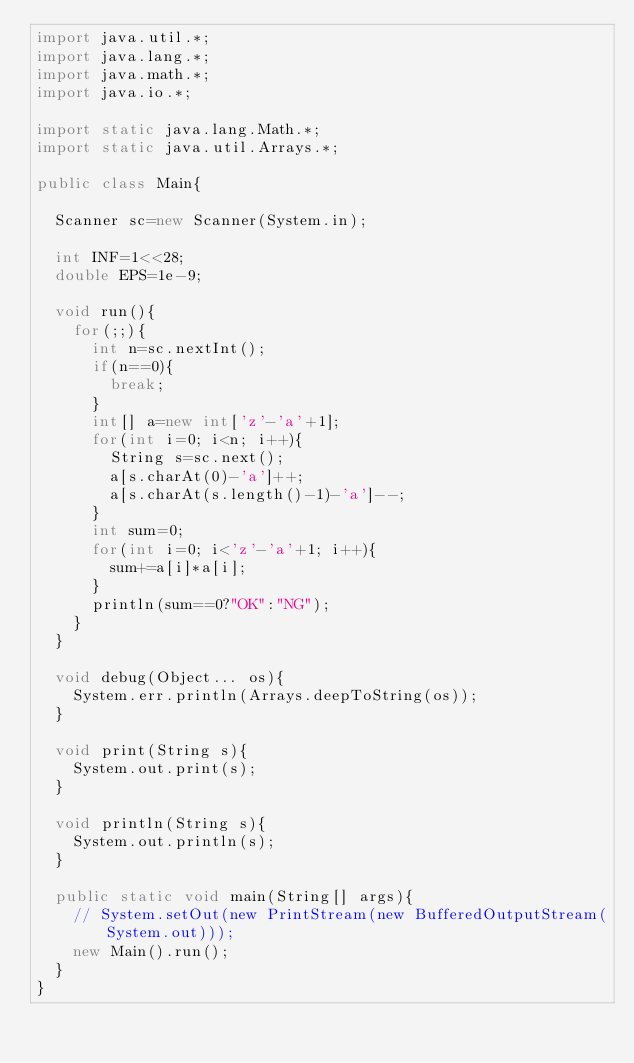Convert code to text. <code><loc_0><loc_0><loc_500><loc_500><_Java_>import java.util.*;
import java.lang.*;
import java.math.*;
import java.io.*;

import static java.lang.Math.*;
import static java.util.Arrays.*;

public class Main{

	Scanner sc=new Scanner(System.in);

	int INF=1<<28;
	double EPS=1e-9;

	void run(){
		for(;;){
			int n=sc.nextInt();
			if(n==0){
				break;
			}
			int[] a=new int['z'-'a'+1];
			for(int i=0; i<n; i++){
				String s=sc.next();
				a[s.charAt(0)-'a']++;
				a[s.charAt(s.length()-1)-'a']--;
			}
			int sum=0;
			for(int i=0; i<'z'-'a'+1; i++){
				sum+=a[i]*a[i];
			}
			println(sum==0?"OK":"NG");
		}
	}

	void debug(Object... os){
		System.err.println(Arrays.deepToString(os));
	}

	void print(String s){
		System.out.print(s);
	}

	void println(String s){
		System.out.println(s);
	}

	public static void main(String[] args){
		// System.setOut(new PrintStream(new BufferedOutputStream(System.out)));
		new Main().run();
	}
}</code> 